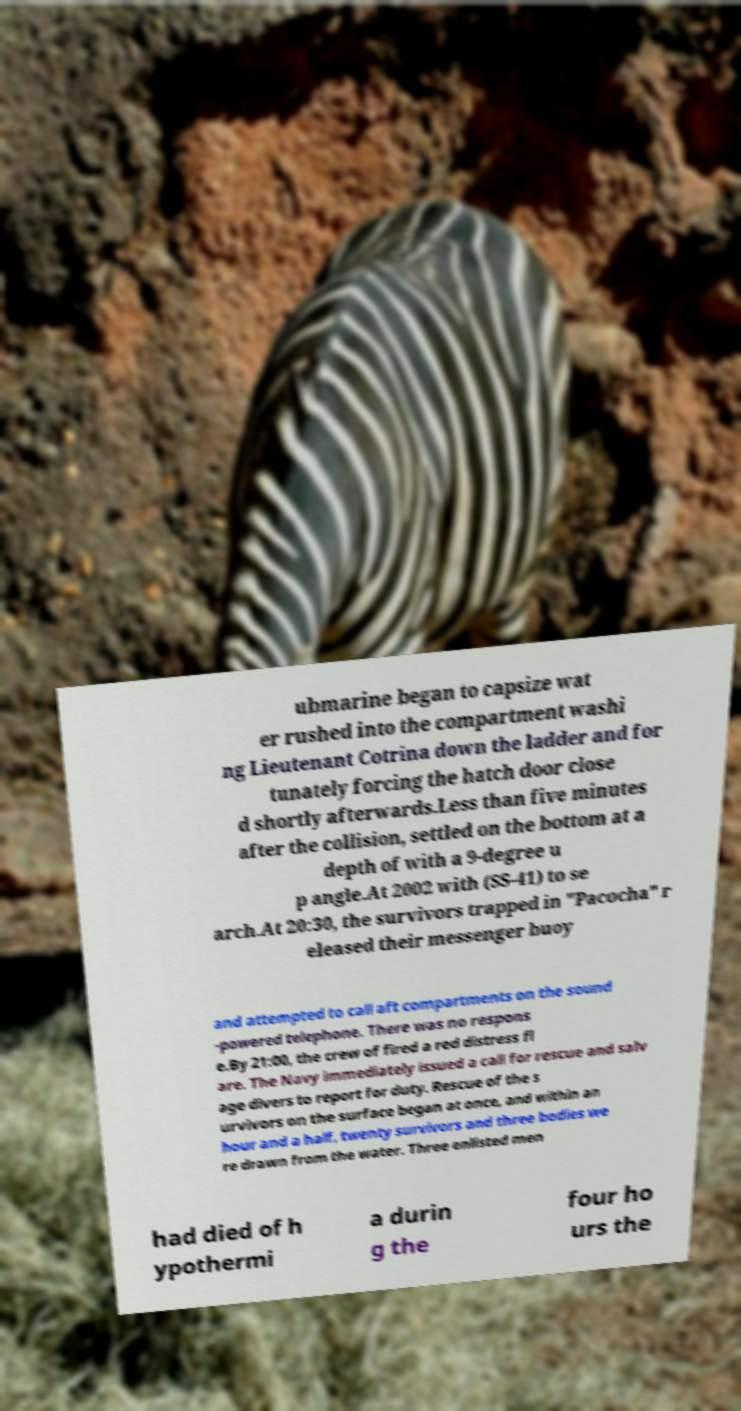Could you assist in decoding the text presented in this image and type it out clearly? ubmarine began to capsize wat er rushed into the compartment washi ng Lieutenant Cotrina down the ladder and for tunately forcing the hatch door close d shortly afterwards.Less than five minutes after the collision, settled on the bottom at a depth of with a 9-degree u p angle.At 2002 with (SS-41) to se arch.At 20:30, the survivors trapped in "Pacocha" r eleased their messenger buoy and attempted to call aft compartments on the sound -powered telephone. There was no respons e.By 21:00, the crew of fired a red distress fl are. The Navy immediately issued a call for rescue and salv age divers to report for duty. Rescue of the s urvivors on the surface began at once, and within an hour and a half, twenty survivors and three bodies we re drawn from the water. Three enlisted men had died of h ypothermi a durin g the four ho urs the 